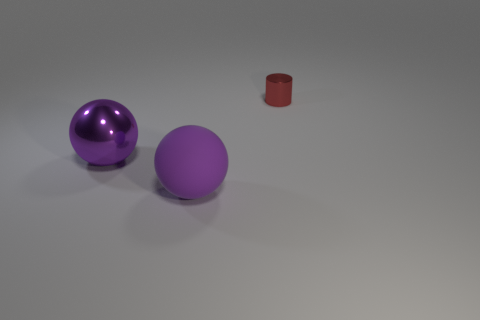Add 3 large red rubber cylinders. How many objects exist? 6 Subtract all balls. How many objects are left? 1 Add 2 purple things. How many purple things are left? 4 Add 2 matte objects. How many matte objects exist? 3 Subtract 0 yellow cylinders. How many objects are left? 3 Subtract all blue cylinders. Subtract all brown spheres. How many cylinders are left? 1 Subtract all blue cubes. How many red balls are left? 0 Subtract all large matte balls. Subtract all balls. How many objects are left? 0 